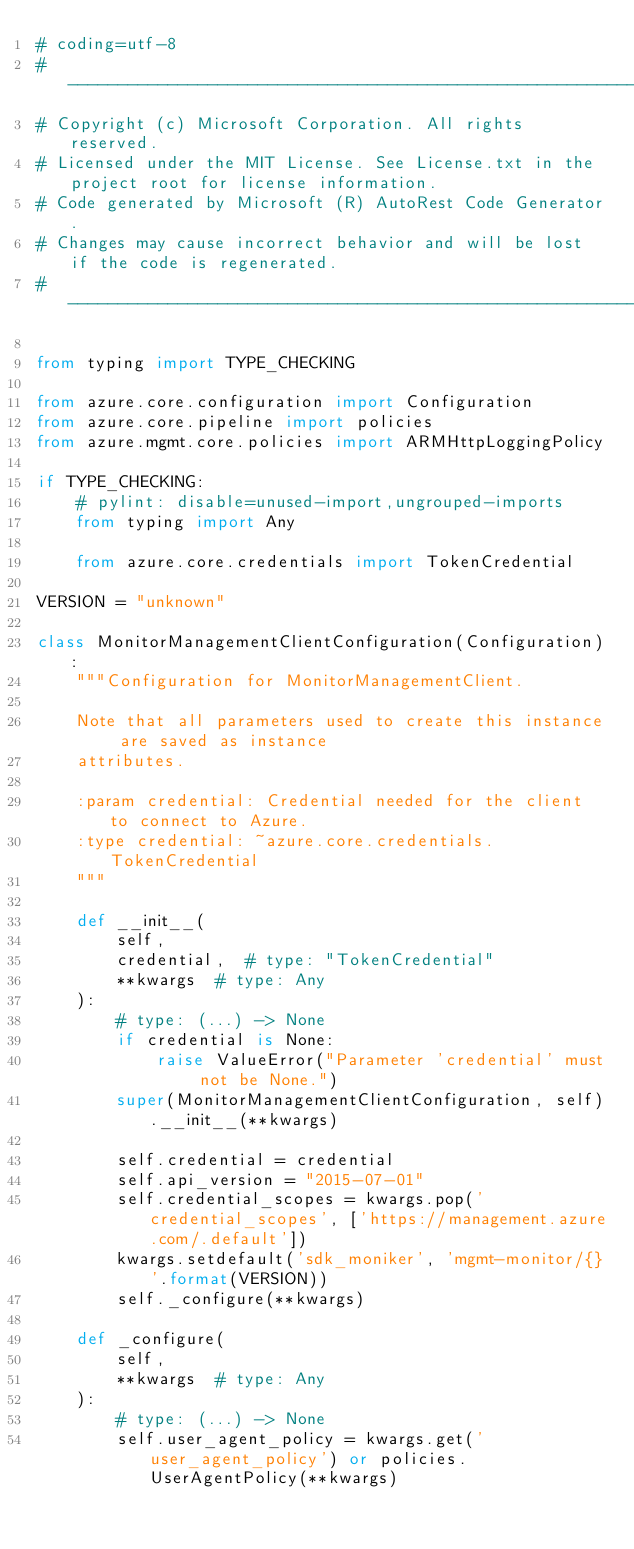<code> <loc_0><loc_0><loc_500><loc_500><_Python_># coding=utf-8
# --------------------------------------------------------------------------
# Copyright (c) Microsoft Corporation. All rights reserved.
# Licensed under the MIT License. See License.txt in the project root for license information.
# Code generated by Microsoft (R) AutoRest Code Generator.
# Changes may cause incorrect behavior and will be lost if the code is regenerated.
# --------------------------------------------------------------------------

from typing import TYPE_CHECKING

from azure.core.configuration import Configuration
from azure.core.pipeline import policies
from azure.mgmt.core.policies import ARMHttpLoggingPolicy

if TYPE_CHECKING:
    # pylint: disable=unused-import,ungrouped-imports
    from typing import Any

    from azure.core.credentials import TokenCredential

VERSION = "unknown"

class MonitorManagementClientConfiguration(Configuration):
    """Configuration for MonitorManagementClient.

    Note that all parameters used to create this instance are saved as instance
    attributes.

    :param credential: Credential needed for the client to connect to Azure.
    :type credential: ~azure.core.credentials.TokenCredential
    """

    def __init__(
        self,
        credential,  # type: "TokenCredential"
        **kwargs  # type: Any
    ):
        # type: (...) -> None
        if credential is None:
            raise ValueError("Parameter 'credential' must not be None.")
        super(MonitorManagementClientConfiguration, self).__init__(**kwargs)

        self.credential = credential
        self.api_version = "2015-07-01"
        self.credential_scopes = kwargs.pop('credential_scopes', ['https://management.azure.com/.default'])
        kwargs.setdefault('sdk_moniker', 'mgmt-monitor/{}'.format(VERSION))
        self._configure(**kwargs)

    def _configure(
        self,
        **kwargs  # type: Any
    ):
        # type: (...) -> None
        self.user_agent_policy = kwargs.get('user_agent_policy') or policies.UserAgentPolicy(**kwargs)</code> 